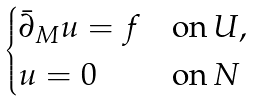<formula> <loc_0><loc_0><loc_500><loc_500>\begin{cases} \bar { \partial } _ { M } u = f & \text {on} \, U , \\ u = 0 & \text {on} \, N \end{cases}</formula> 